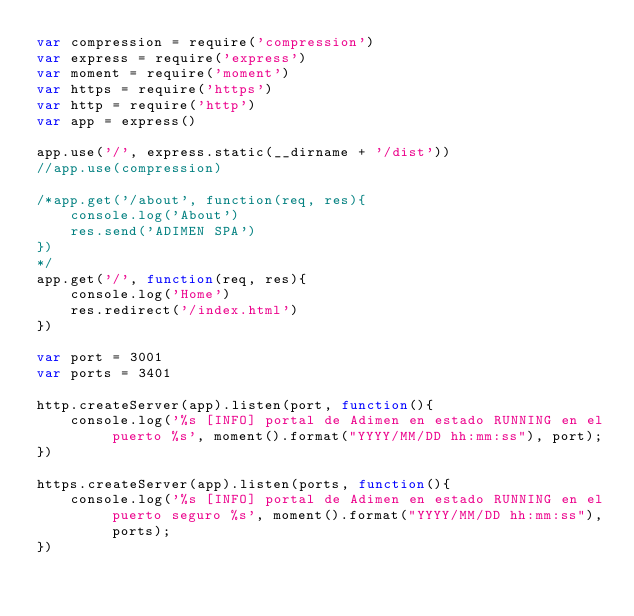<code> <loc_0><loc_0><loc_500><loc_500><_JavaScript_>var compression = require('compression')
var express = require('express')
var moment = require('moment')
var https = require('https')
var http = require('http')
var app = express()

app.use('/', express.static(__dirname + '/dist'))
//app.use(compression)

/*app.get('/about', function(req, res){
    console.log('About')
    res.send('ADIMEN SPA')
})
*/
app.get('/', function(req, res){
    console.log('Home')
    res.redirect('/index.html')
})

var port = 3001
var ports = 3401

http.createServer(app).listen(port, function(){
    console.log('%s [INFO] portal de Adimen en estado RUNNING en el puerto %s', moment().format("YYYY/MM/DD hh:mm:ss"), port);
})

https.createServer(app).listen(ports, function(){
    console.log('%s [INFO] portal de Adimen en estado RUNNING en el puerto seguro %s', moment().format("YYYY/MM/DD hh:mm:ss"), ports);
})
</code> 